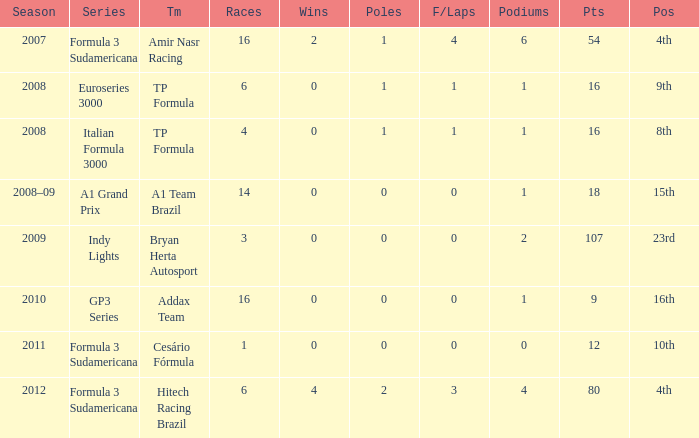How many points did he win in the race with more than 1.0 poles? 80.0. 